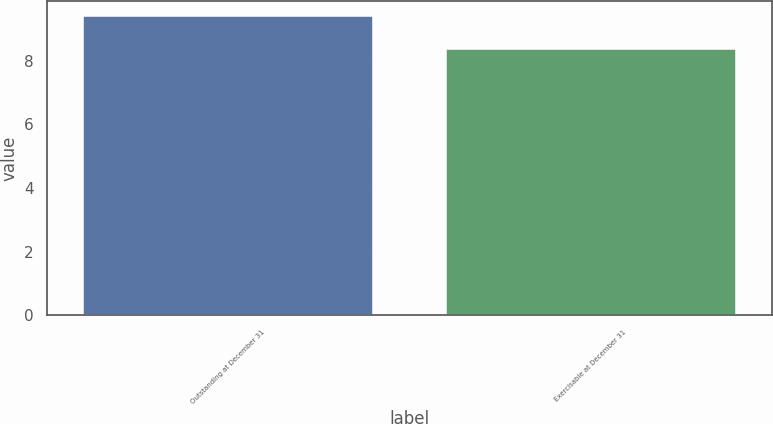Convert chart to OTSL. <chart><loc_0><loc_0><loc_500><loc_500><bar_chart><fcel>Outstanding at December 31<fcel>Exercisable at December 31<nl><fcel>9.42<fcel>8.36<nl></chart> 